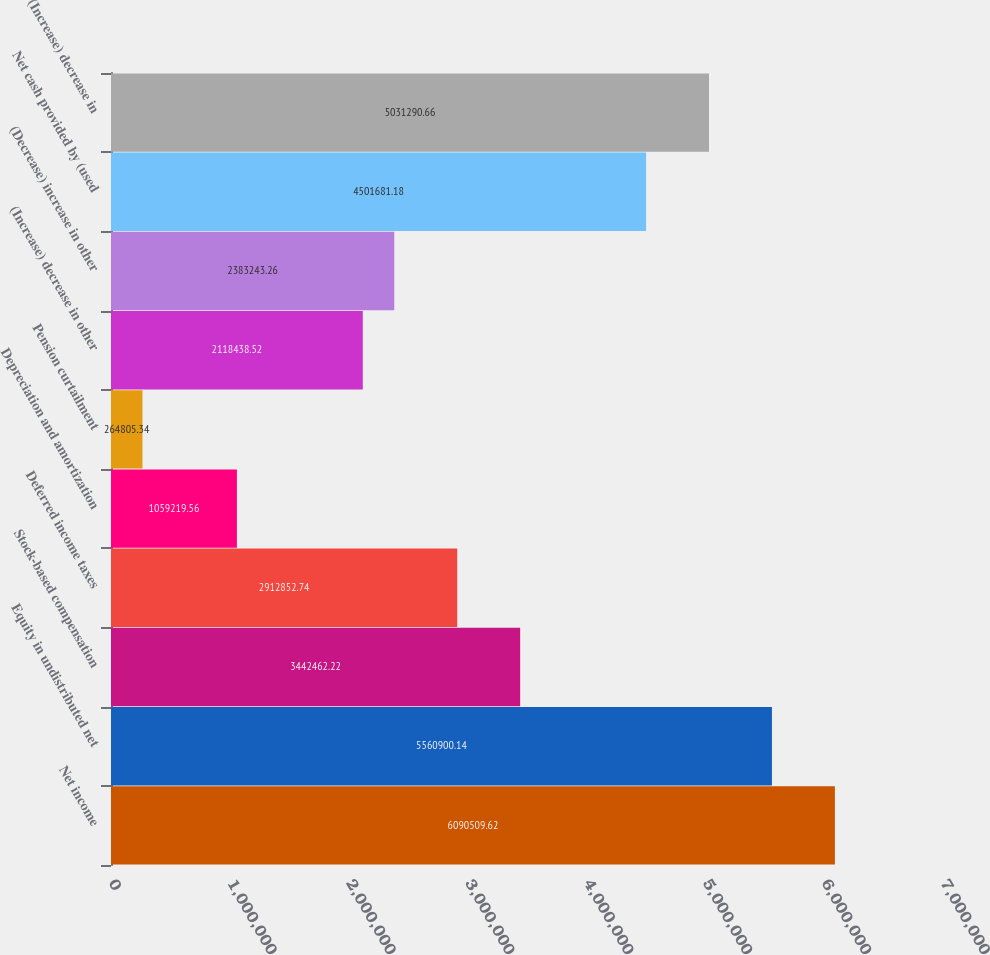Convert chart. <chart><loc_0><loc_0><loc_500><loc_500><bar_chart><fcel>Net income<fcel>Equity in undistributed net<fcel>Stock-based compensation<fcel>Deferred income taxes<fcel>Depreciation and amortization<fcel>Pension curtailment<fcel>(Increase) decrease in other<fcel>(Decrease) increase in other<fcel>Net cash provided by (used<fcel>(Increase) decrease in<nl><fcel>6.09051e+06<fcel>5.5609e+06<fcel>3.44246e+06<fcel>2.91285e+06<fcel>1.05922e+06<fcel>264805<fcel>2.11844e+06<fcel>2.38324e+06<fcel>4.50168e+06<fcel>5.03129e+06<nl></chart> 